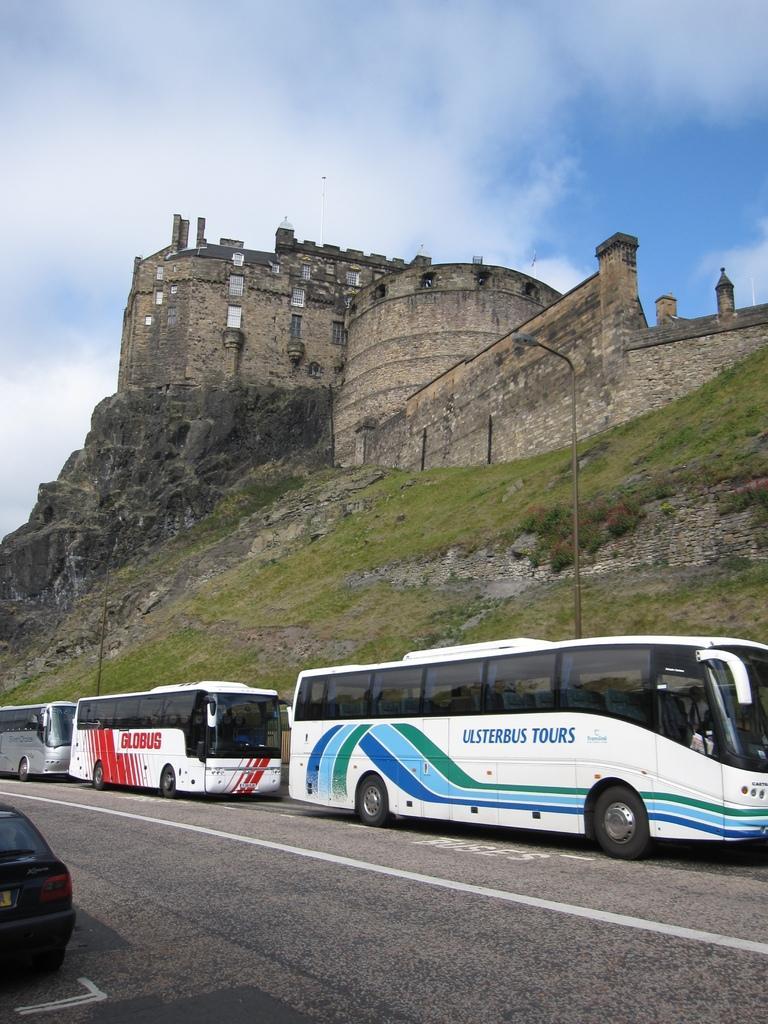How would you summarize this image in a sentence or two? At the bottom of the image there is road. On the road there are few vehicles. Behind the vehicles there is a hill with poles and also there is a grass. On the top of the hill there is a fort with walls, windows and pillars. At the top of the image there is a sky with clouds. 